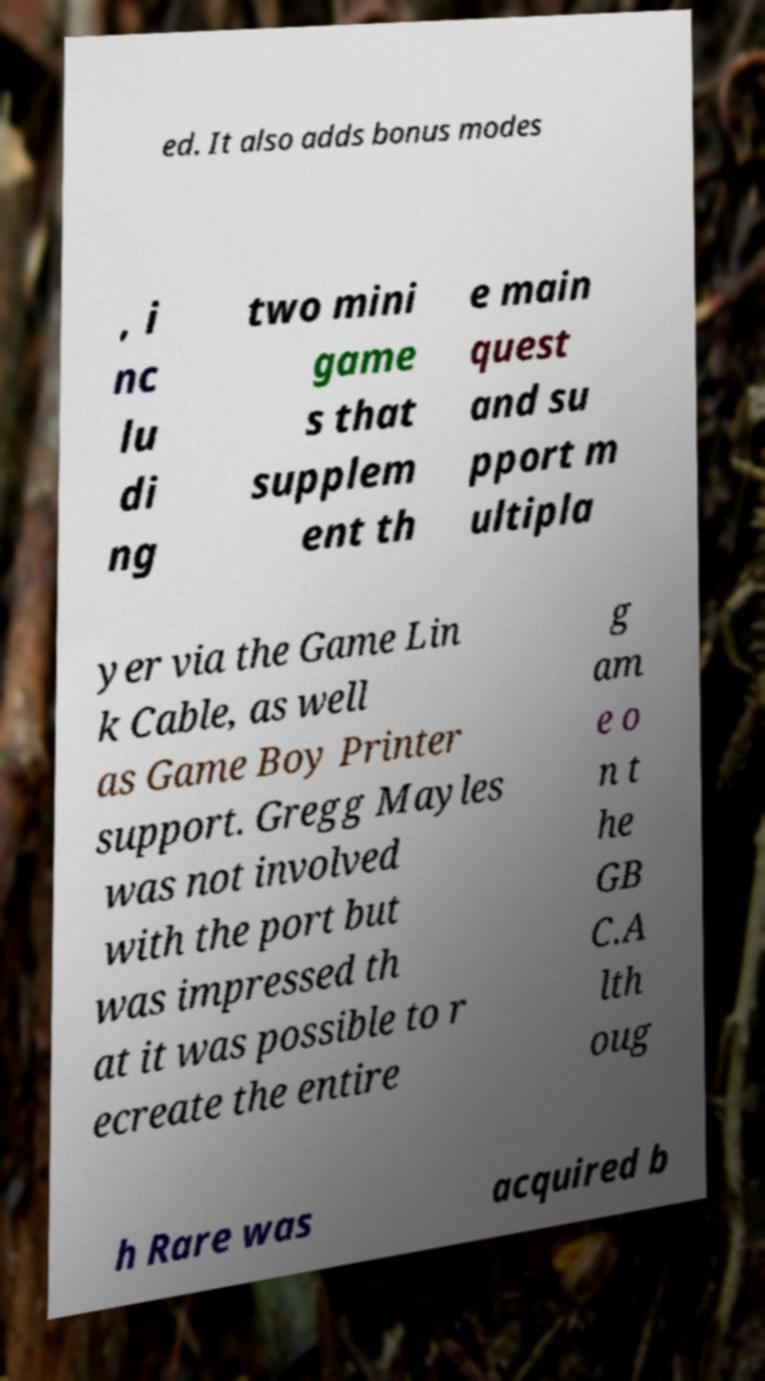Please identify and transcribe the text found in this image. ed. It also adds bonus modes , i nc lu di ng two mini game s that supplem ent th e main quest and su pport m ultipla yer via the Game Lin k Cable, as well as Game Boy Printer support. Gregg Mayles was not involved with the port but was impressed th at it was possible to r ecreate the entire g am e o n t he GB C.A lth oug h Rare was acquired b 